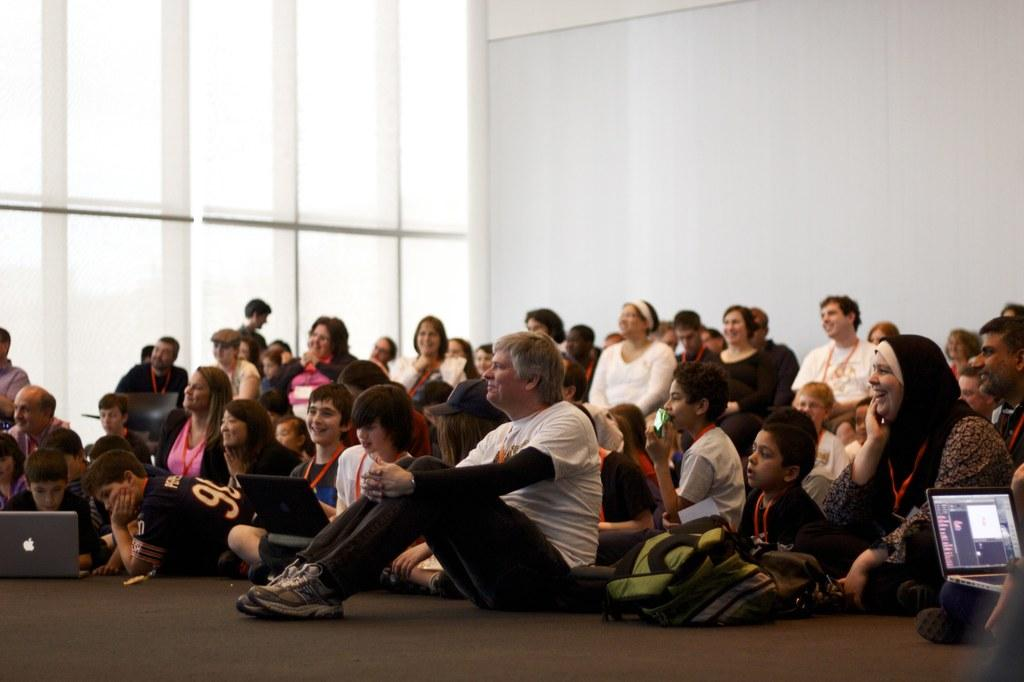How many kids are in the image? There are many kids in the image. What are the people in the image doing? The people are sitting on the floor in the image. What is the facial expression of the people in the image? The people are smiling at someone. What electronic devices can be seen in the image? There are laptops visible in the image. What type of songs can be heard in the background of the image? There is no audio or background music present in the image, so it is not possible to determine what songs might be heard. 